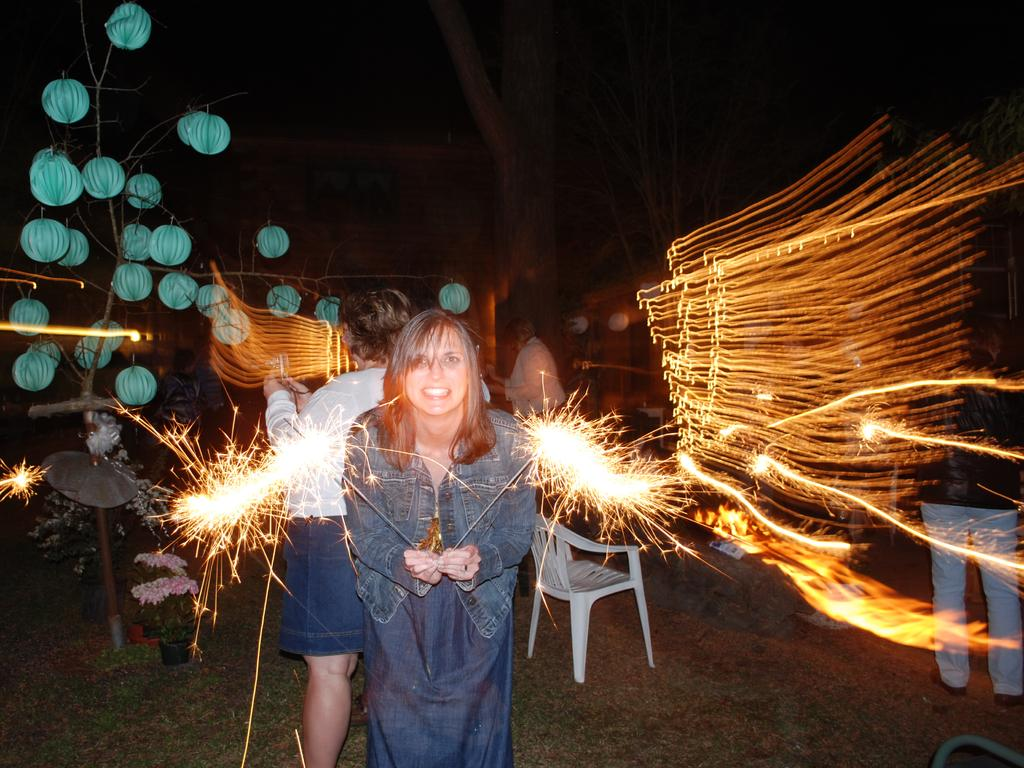Who is present in the image? There are two persons in the image, one of whom is a woman. What is the woman holding in the image? The woman is holding crackers. What decorative objects can be seen in the image? There are decorative balls in the image. What type of furniture is present in the image? There is a chair in the image. What type of lighting is present in the image? There are lights in the image. What type of food is present in the image? There are crackers in the image. What is the background of the image like? The background of the image is dark. What type of natural scenery is visible in the image? Trees are visible in the image. What type of error can be seen in the image? There is no error present in the image. What type of sheet is visible in the image? There is no sheet present in the image. 